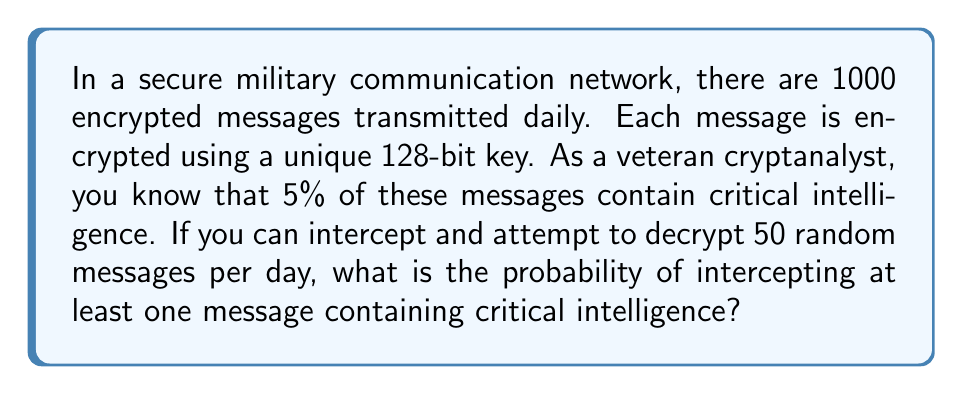What is the answer to this math problem? Let's approach this step-by-step:

1) First, we need to calculate the probability of not intercepting a critical message in a single attempt.
   - Total messages: 1000
   - Critical messages: 5% of 1000 = 50
   - Probability of intercepting a non-critical message = $\frac{950}{1000} = 0.95$

2) Now, we need to find the probability of not intercepting any critical messages in 50 attempts.
   - This is equivalent to intercepting only non-critical messages 50 times in a row.
   - Probability = $0.95^{50}$

3) We can calculate this:
   $$0.95^{50} \approx 0.0769$$

4) This is the probability of not intercepting any critical messages. We want the probability of intercepting at least one, which is the complement of this probability.

5) Probability of intercepting at least one critical message:
   $$1 - 0.95^{50} \approx 1 - 0.0769 = 0.9231$$

6) Convert to percentage:
   $$0.9231 \times 100\% = 92.31\%$$
Answer: $92.31\%$ 